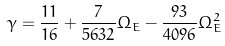<formula> <loc_0><loc_0><loc_500><loc_500>\gamma = \frac { 1 1 } { 1 6 } + \frac { 7 } { 5 6 3 2 } \Omega _ { E } - \frac { 9 3 } { 4 0 9 6 } \Omega _ { E } ^ { 2 }</formula> 